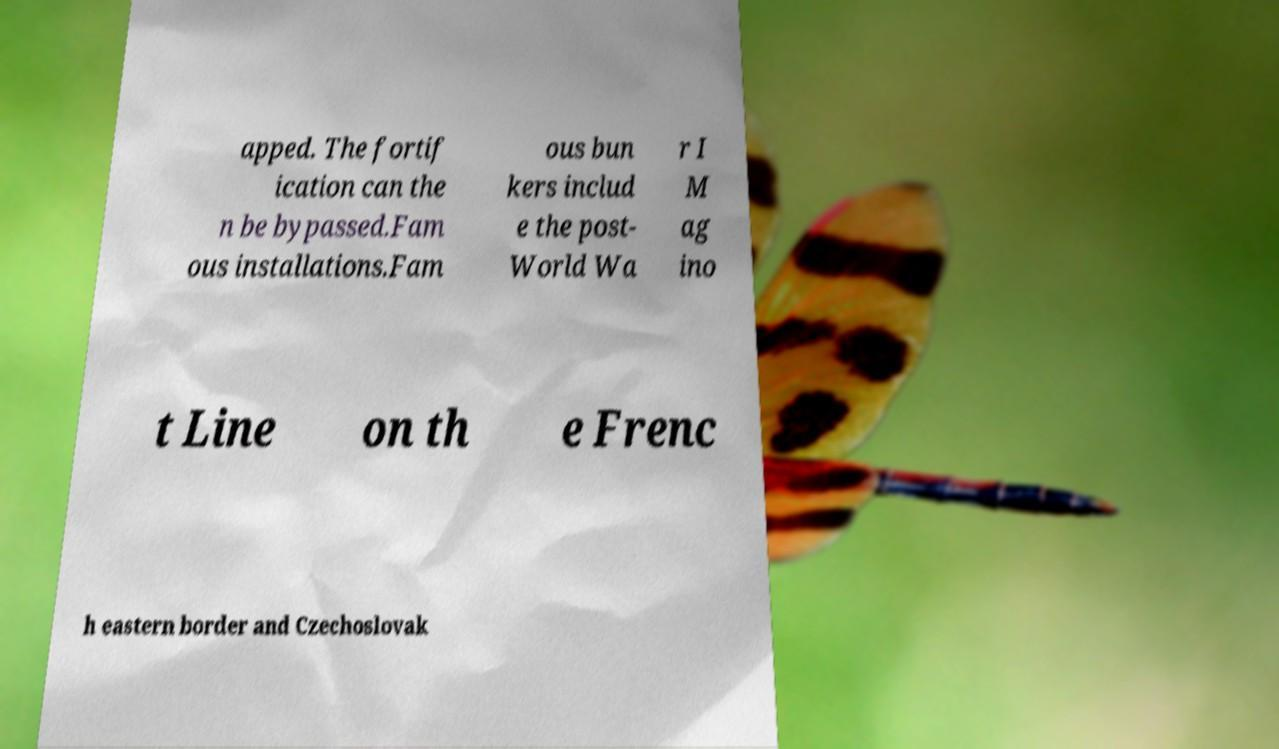Please identify and transcribe the text found in this image. apped. The fortif ication can the n be bypassed.Fam ous installations.Fam ous bun kers includ e the post- World Wa r I M ag ino t Line on th e Frenc h eastern border and Czechoslovak 